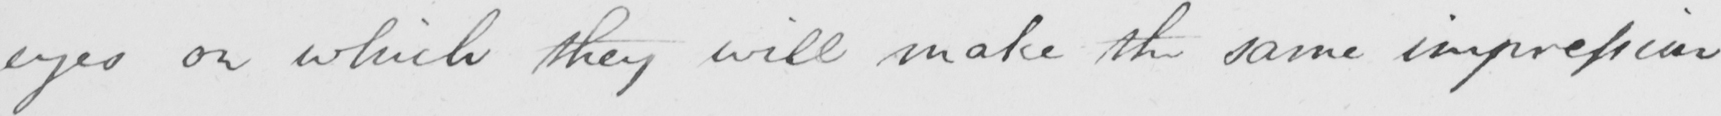What text is written in this handwritten line? eyes on which they will make the same impression 